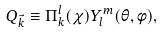Convert formula to latex. <formula><loc_0><loc_0><loc_500><loc_500>Q _ { \vec { k } } \equiv \Pi _ { k } ^ { l } ( \chi ) Y _ { l } ^ { m } ( \theta , \phi ) ,</formula> 